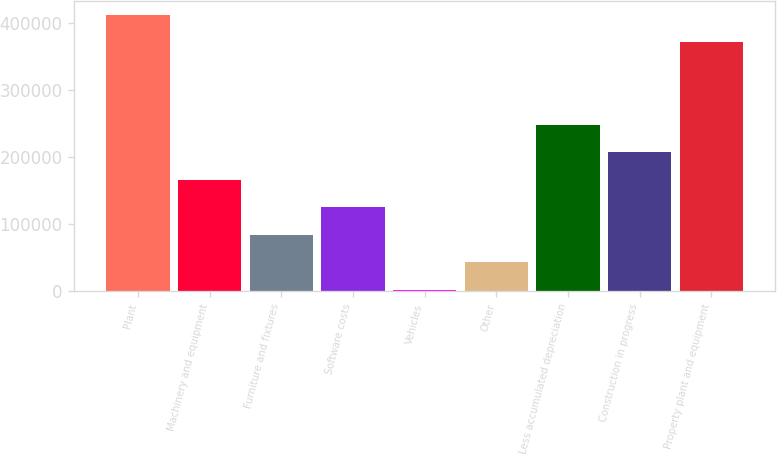Convert chart. <chart><loc_0><loc_0><loc_500><loc_500><bar_chart><fcel>Plant<fcel>Machinery and equipment<fcel>Furniture and fixtures<fcel>Software costs<fcel>Vehicles<fcel>Other<fcel>Less accumulated depreciation<fcel>Construction in progress<fcel>Property plant and equipment<nl><fcel>411706<fcel>165754<fcel>83770<fcel>124762<fcel>1786<fcel>42778<fcel>247738<fcel>206746<fcel>370495<nl></chart> 